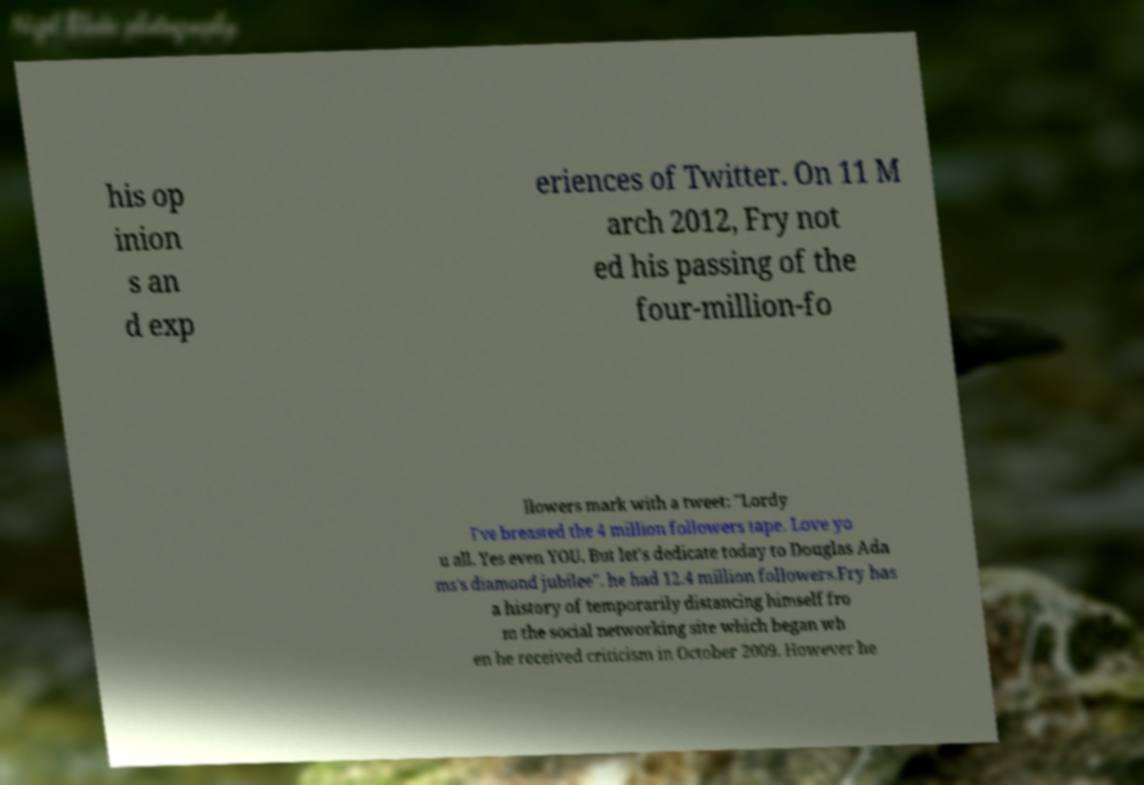Can you read and provide the text displayed in the image?This photo seems to have some interesting text. Can you extract and type it out for me? his op inion s an d exp eriences of Twitter. On 11 M arch 2012, Fry not ed his passing of the four-million-fo llowers mark with a tweet: "Lordy I've breasted the 4 million followers tape. Love yo u all. Yes even YOU. But let's dedicate today to Douglas Ada ms's diamond jubilee". he had 12.4 million followers.Fry has a history of temporarily distancing himself fro m the social networking site which began wh en he received criticism in October 2009. However he 